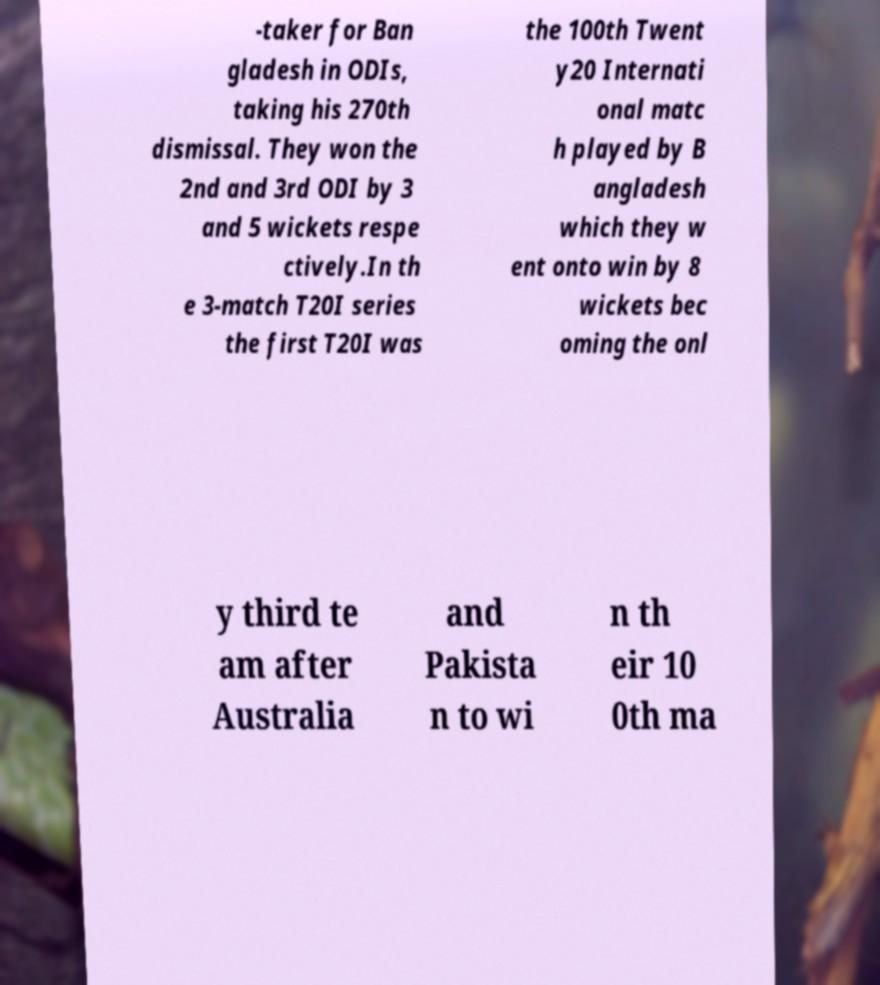Please identify and transcribe the text found in this image. -taker for Ban gladesh in ODIs, taking his 270th dismissal. They won the 2nd and 3rd ODI by 3 and 5 wickets respe ctively.In th e 3-match T20I series the first T20I was the 100th Twent y20 Internati onal matc h played by B angladesh which they w ent onto win by 8 wickets bec oming the onl y third te am after Australia and Pakista n to wi n th eir 10 0th ma 